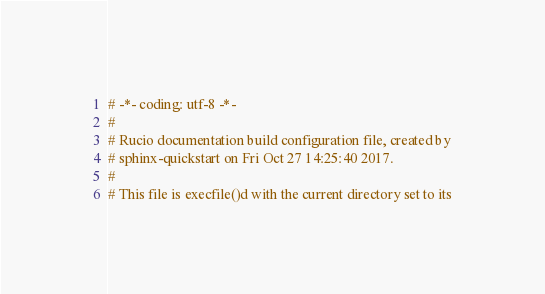<code> <loc_0><loc_0><loc_500><loc_500><_Python_># -*- coding: utf-8 -*-
#
# Rucio documentation build configuration file, created by
# sphinx-quickstart on Fri Oct 27 14:25:40 2017.
#
# This file is execfile()d with the current directory set to its</code> 